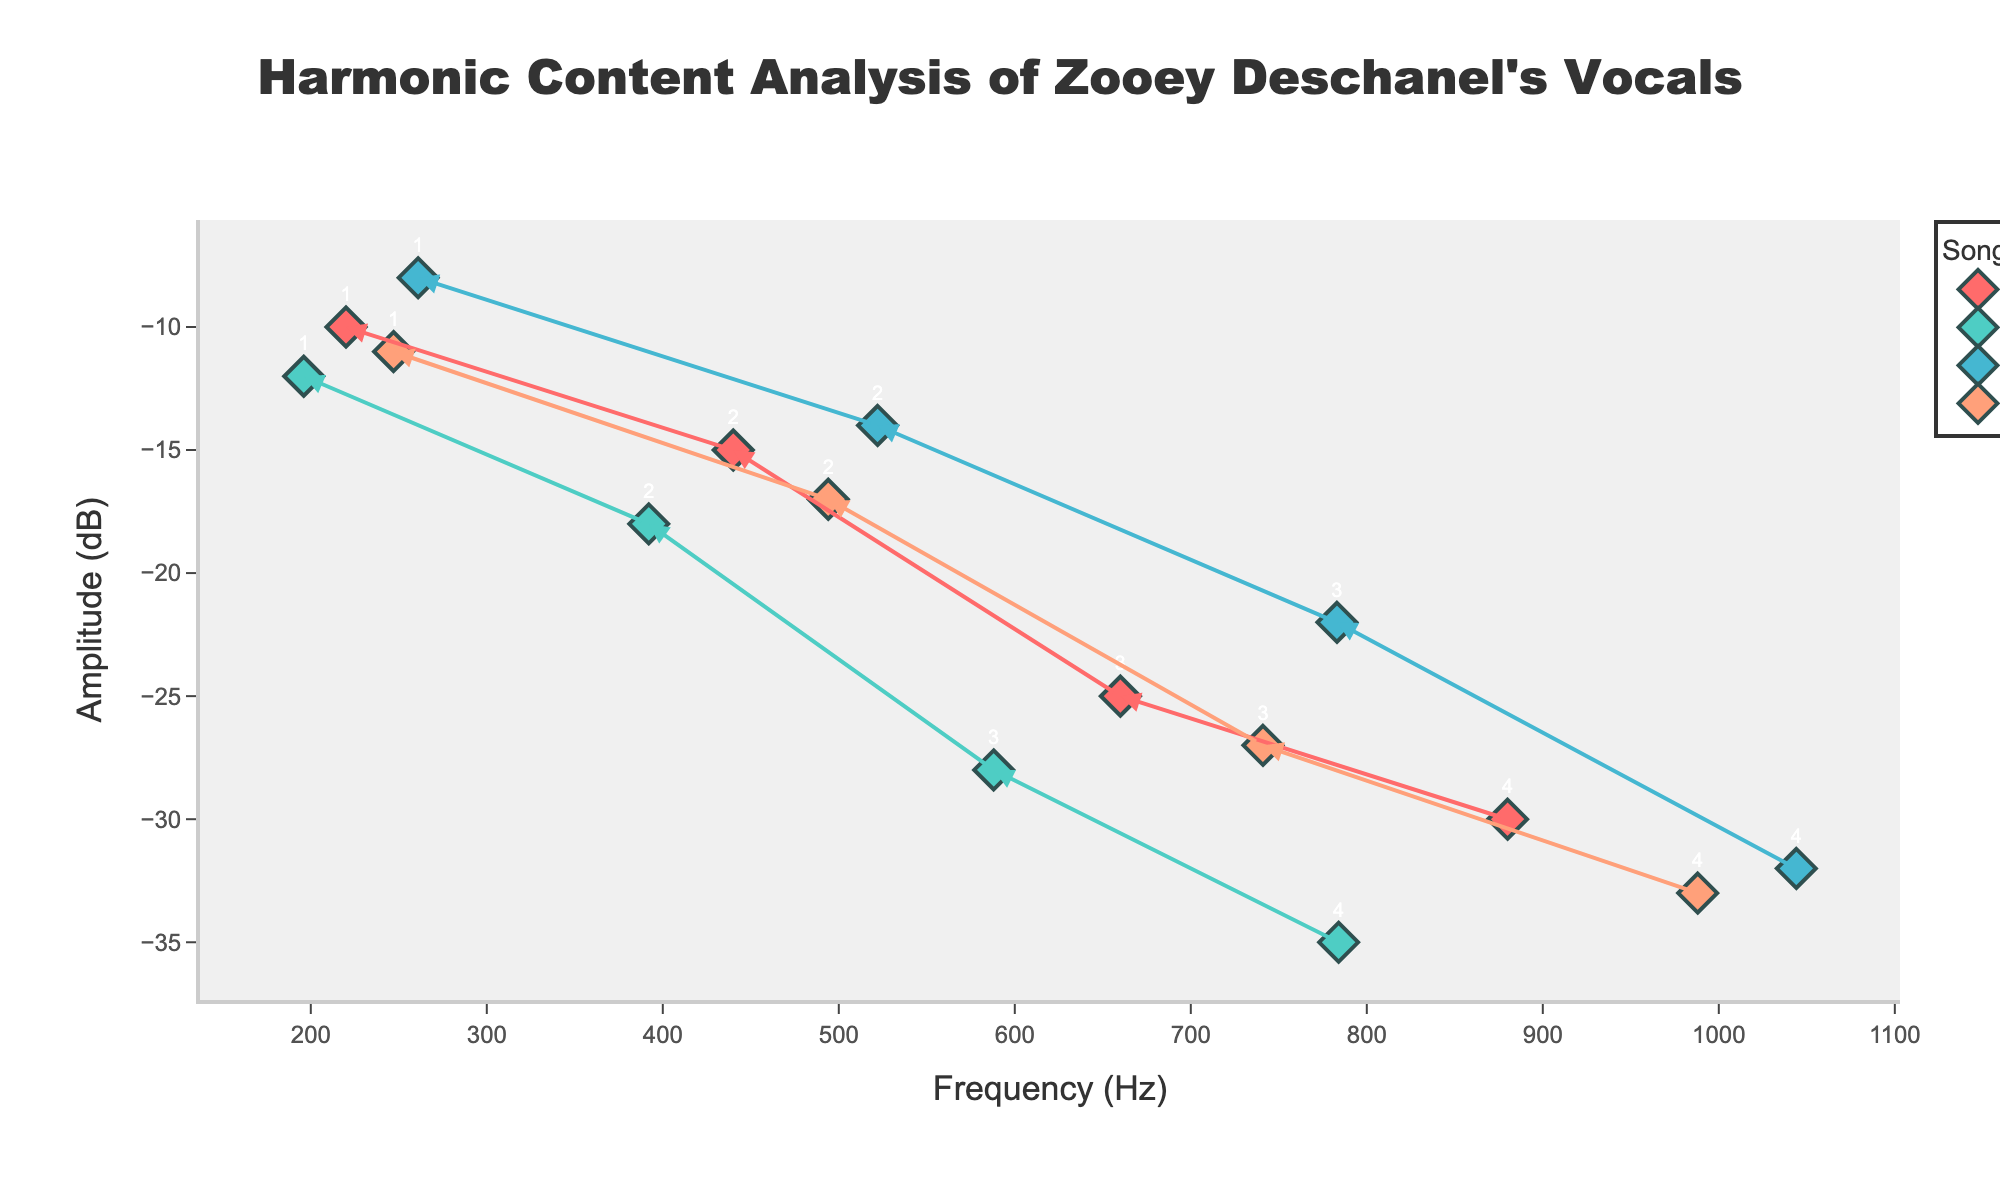1. What is the title of the figure? The title is shown at the top of the figure. It gives an overview of what the plot represents.
Answer: Harmonic Content Analysis of Zooey Deschanel's Vocals 2. Which song has the highest frequency harmonic? Identify the maximum x-axis value corresponding to the frequency and note the associated song. The highest frequency value is 1044 Hz.
Answer: She & Him - Stay Awhile 3. What is the amplitude for the first harmonic order of "She & Him - In the Sun"? Locate the point labeled with harmonic order 1 for "She & Him - In the Sun" on the plot and note its y-axis position.
Answer: -10 dB 4. How does the amplitude of the harmonics generally change as the frequency increases for "She & Him - Why Do You Let Me Stay Here?"? Observe the general trend of the points for "She & Him - Why Do You Let Me Stay Here?" from left to right (increasing frequency).
Answer: It generally decreases 5. Which song has the lowest amplitude among the second harmonics? Identify the points with harmonic order 2 and compare their y-axis (amplitude) values to find the lowest one.
Answer: She & Him - Why Do You Let Me Stay Here? 6. Compare the amplitude of the third harmonic order between "She & Him - Stay Awhile" and "She & Him - Sweet Darlin'". Which one is higher? Identify the points labeled with harmonic order 3 for both songs and compare their y-axis positions.
Answer: She & Him - Stay Awhile 7. What is the amplitude difference between the first harmonic orders of "She & Him - In the Sun" and "She & Him - Sweet Darlin'"? Locate the first harmonic order points of both songs on the y-axis and calculate the difference. (-10 dB for "In the Sun" and -11 dB for "Sweet Darlin'").
Answer: 1 dB 8. What is the average amplitude of the first harmonics for all songs? Find the amplitude values for the first harmonics of all songs (-10, -12, -8, -11) and calculate the average. (-10 + -12 + -8 + -11) / 4 = -10.25
Answer: -10.25 dB 9. What is the trend between the harmonic order and frequency for "She & Him - Stay Awhile"? Observe how the frequency changes with increasing harmonic order for "She & Him - Stay Awhile".
Answer: It increases 